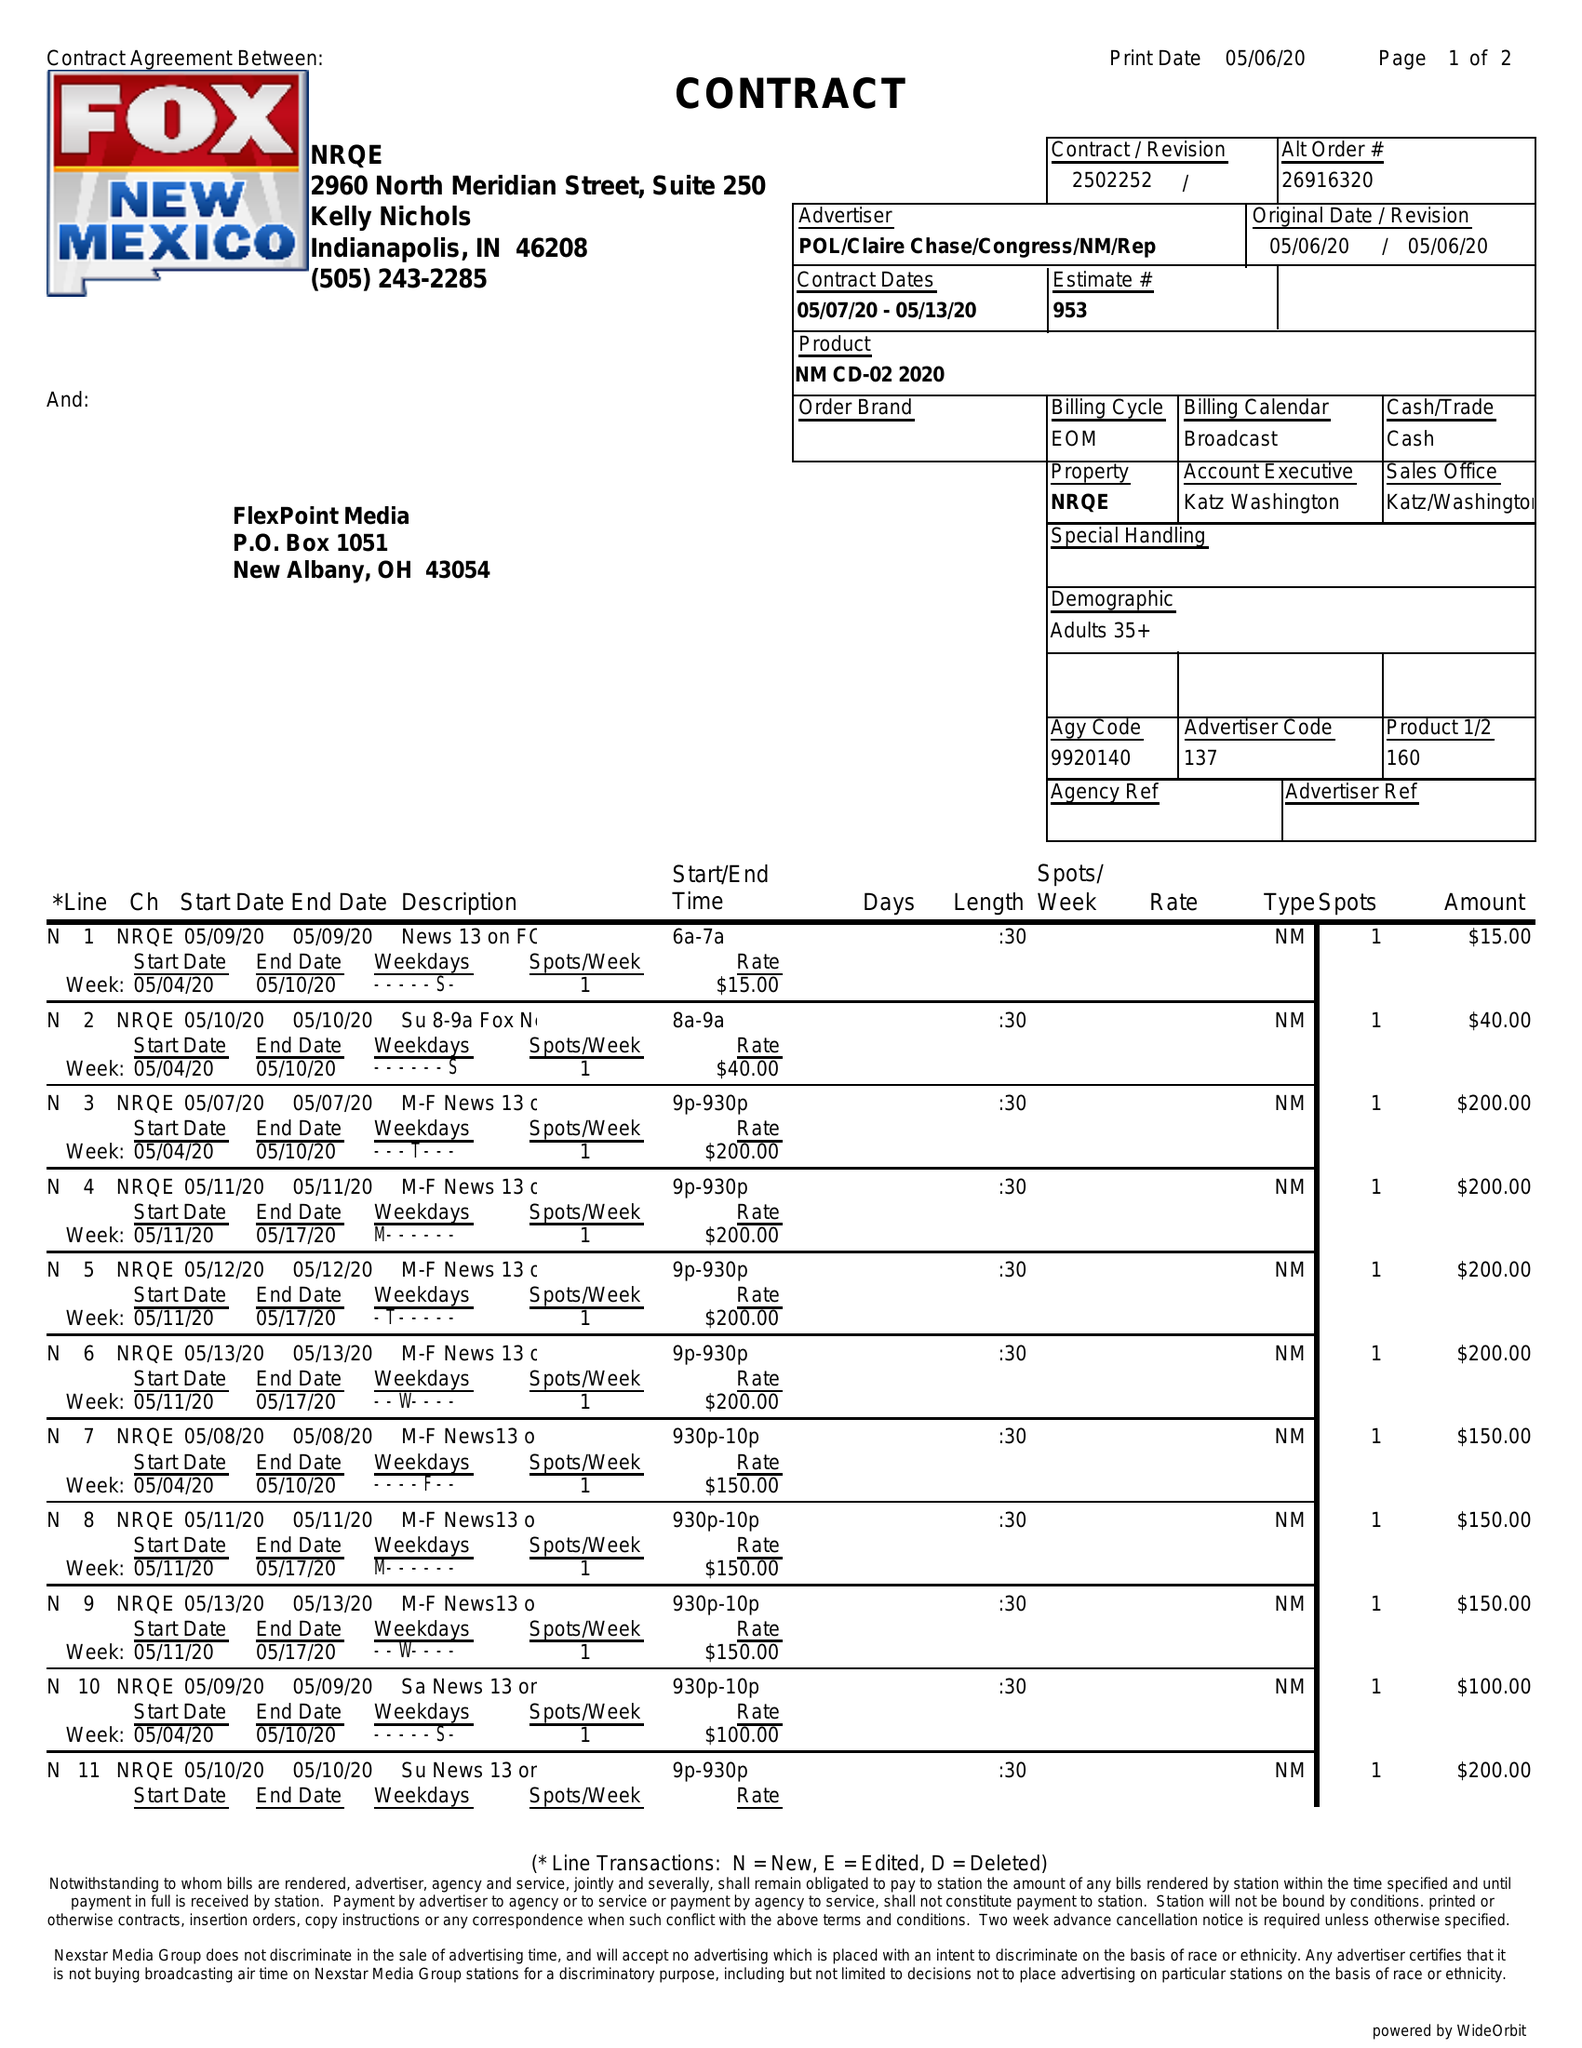What is the value for the gross_amount?
Answer the question using a single word or phrase. 1955.00 